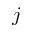Convert formula to latex. <formula><loc_0><loc_0><loc_500><loc_500>j</formula> 